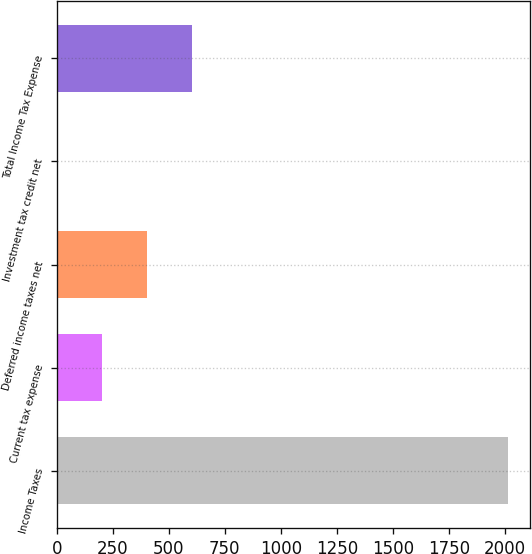Convert chart to OTSL. <chart><loc_0><loc_0><loc_500><loc_500><bar_chart><fcel>Income Taxes<fcel>Current tax expense<fcel>Deferred income taxes net<fcel>Investment tax credit net<fcel>Total Income Tax Expense<nl><fcel>2012<fcel>202.28<fcel>403.36<fcel>1.2<fcel>604.44<nl></chart> 